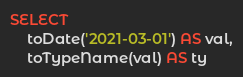Convert code to text. <code><loc_0><loc_0><loc_500><loc_500><_SQL_>SELECT
    toDate('2021-03-01') AS val,
    toTypeName(val) AS ty
</code> 